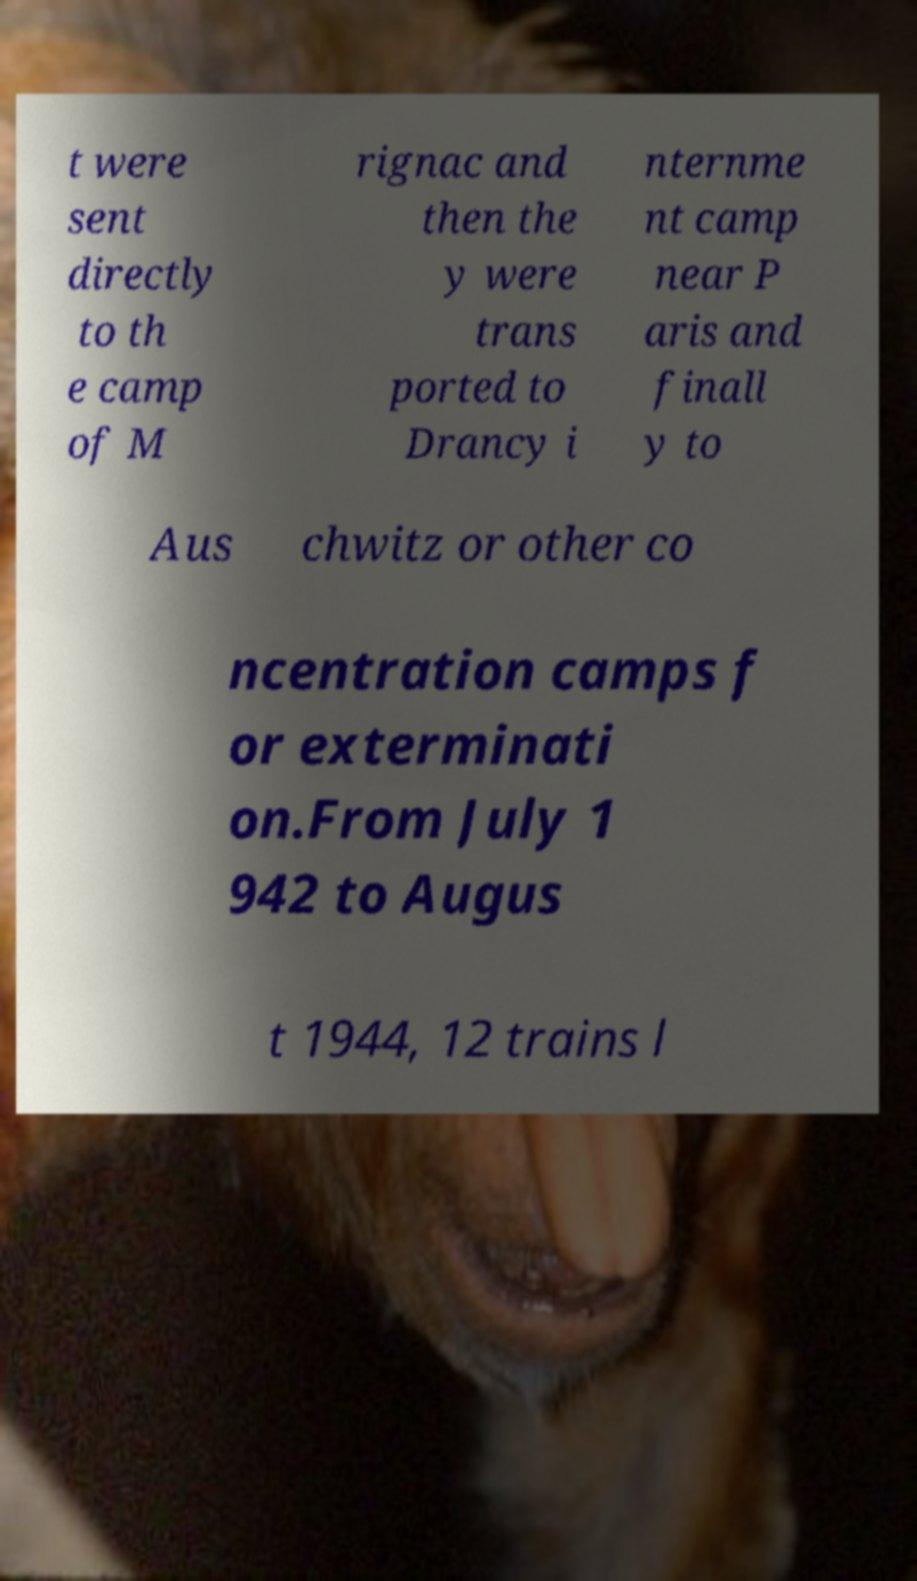What messages or text are displayed in this image? I need them in a readable, typed format. t were sent directly to th e camp of M rignac and then the y were trans ported to Drancy i nternme nt camp near P aris and finall y to Aus chwitz or other co ncentration camps f or exterminati on.From July 1 942 to Augus t 1944, 12 trains l 